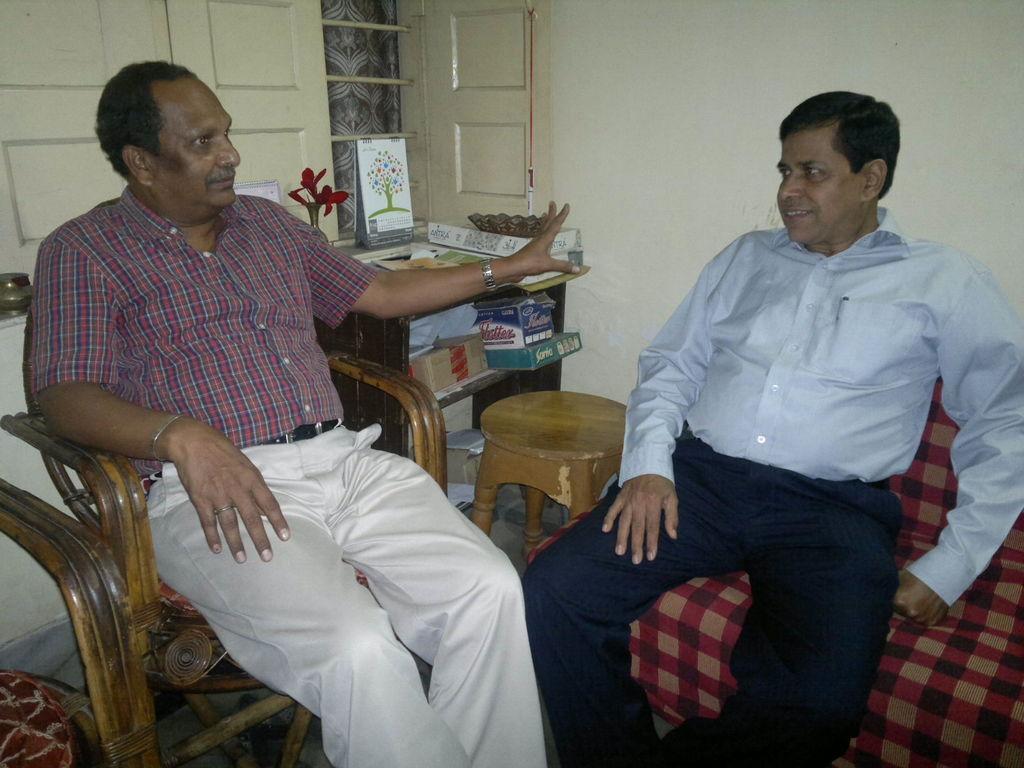Can you describe this image briefly? This picture shows two men seated on the chair and a man speaking and we see a table and a window 